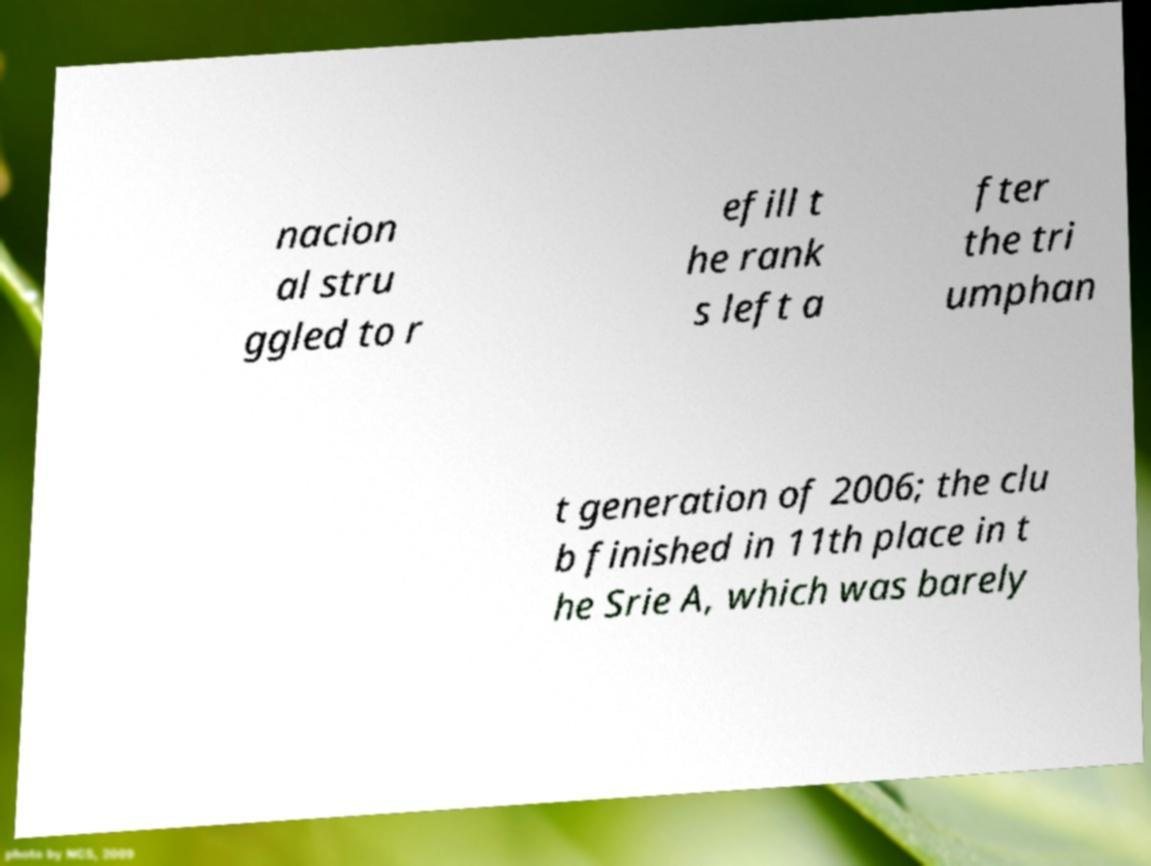Please identify and transcribe the text found in this image. nacion al stru ggled to r efill t he rank s left a fter the tri umphan t generation of 2006; the clu b finished in 11th place in t he Srie A, which was barely 